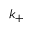Convert formula to latex. <formula><loc_0><loc_0><loc_500><loc_500>k _ { + }</formula> 